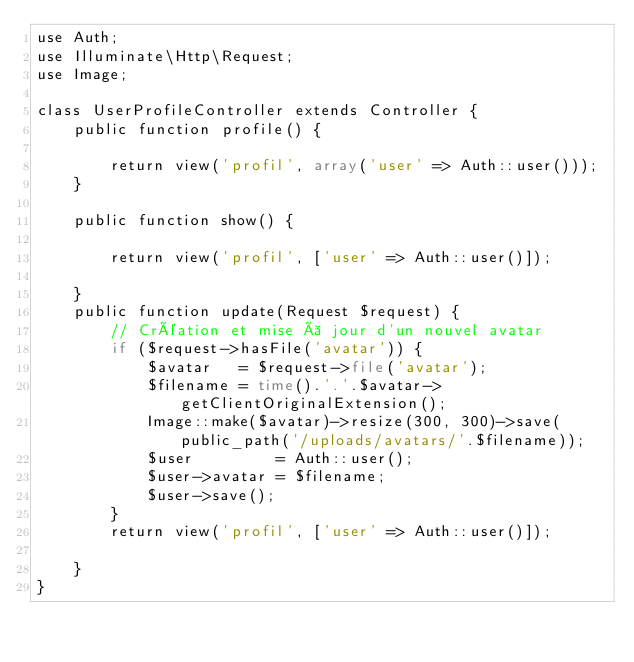Convert code to text. <code><loc_0><loc_0><loc_500><loc_500><_PHP_>use Auth;
use Illuminate\Http\Request;
use Image;

class UserProfileController extends Controller {
	public function profile() {

		return view('profil', array('user' => Auth::user()));
	}

	public function show() {

		return view('profil', ['user' => Auth::user()]);

	}
	public function update(Request $request) {
		// Création et mise à jour d'un nouvel avatar
		if ($request->hasFile('avatar')) {
			$avatar   = $request->file('avatar');
			$filename = time().'.'.$avatar->getClientOriginalExtension();
			Image::make($avatar)->resize(300, 300)->save(public_path('/uploads/avatars/'.$filename));
			$user         = Auth::user();
			$user->avatar = $filename;
			$user->save();
		}
		return view('profil', ['user' => Auth::user()]);

	}
}
</code> 